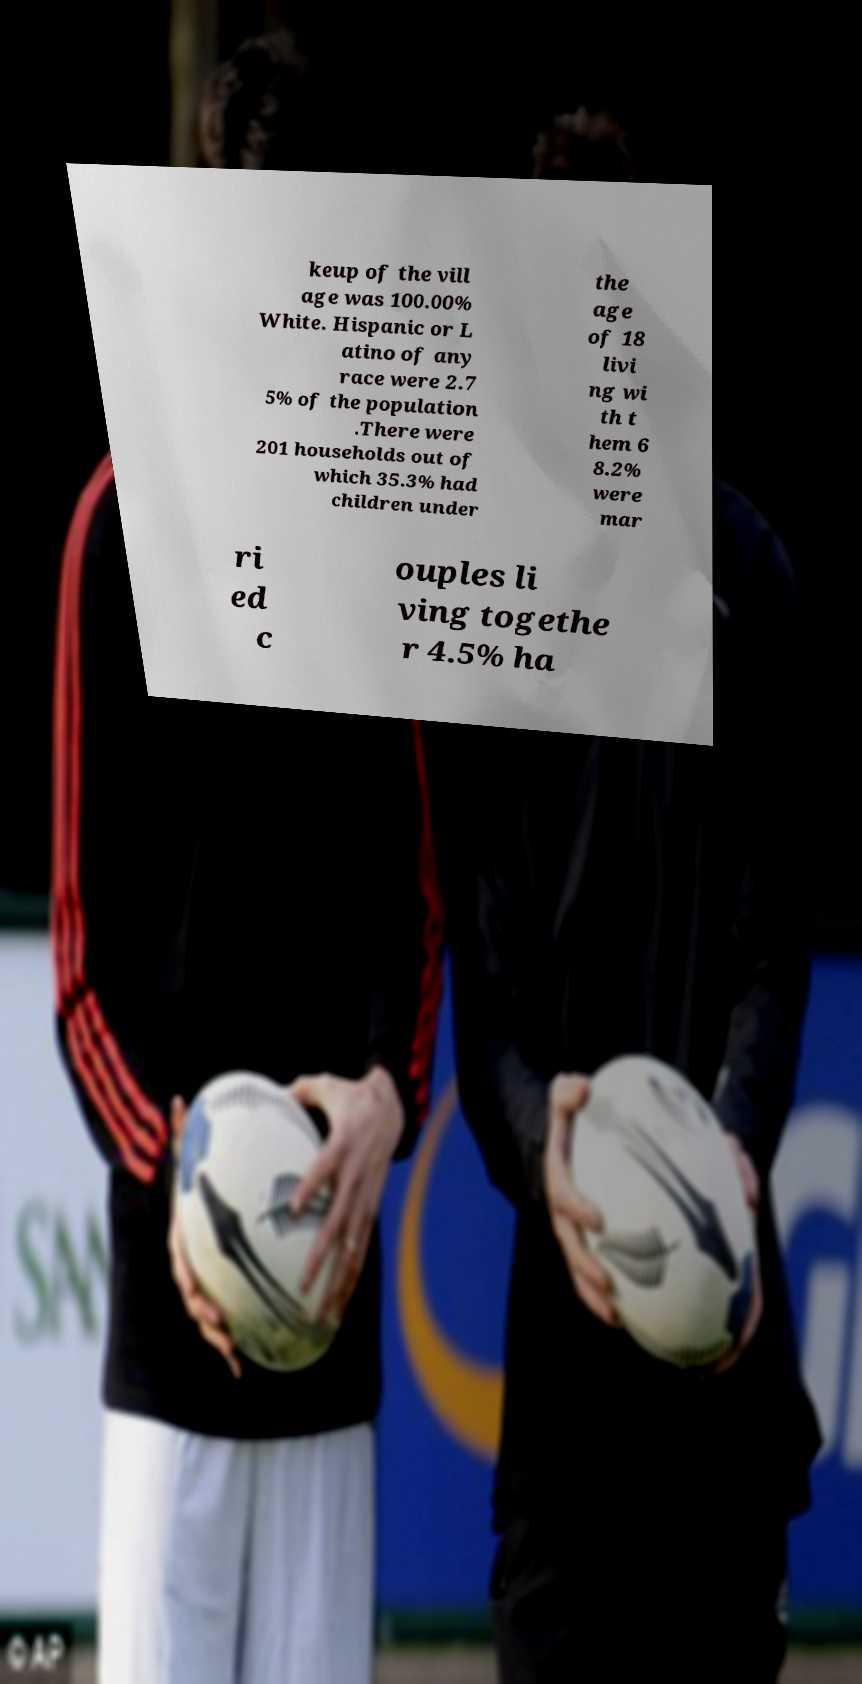Could you assist in decoding the text presented in this image and type it out clearly? keup of the vill age was 100.00% White. Hispanic or L atino of any race were 2.7 5% of the population .There were 201 households out of which 35.3% had children under the age of 18 livi ng wi th t hem 6 8.2% were mar ri ed c ouples li ving togethe r 4.5% ha 